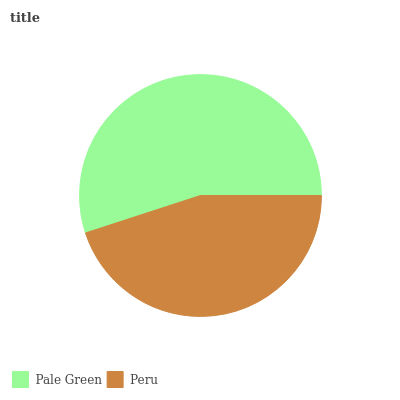Is Peru the minimum?
Answer yes or no. Yes. Is Pale Green the maximum?
Answer yes or no. Yes. Is Peru the maximum?
Answer yes or no. No. Is Pale Green greater than Peru?
Answer yes or no. Yes. Is Peru less than Pale Green?
Answer yes or no. Yes. Is Peru greater than Pale Green?
Answer yes or no. No. Is Pale Green less than Peru?
Answer yes or no. No. Is Pale Green the high median?
Answer yes or no. Yes. Is Peru the low median?
Answer yes or no. Yes. Is Peru the high median?
Answer yes or no. No. Is Pale Green the low median?
Answer yes or no. No. 